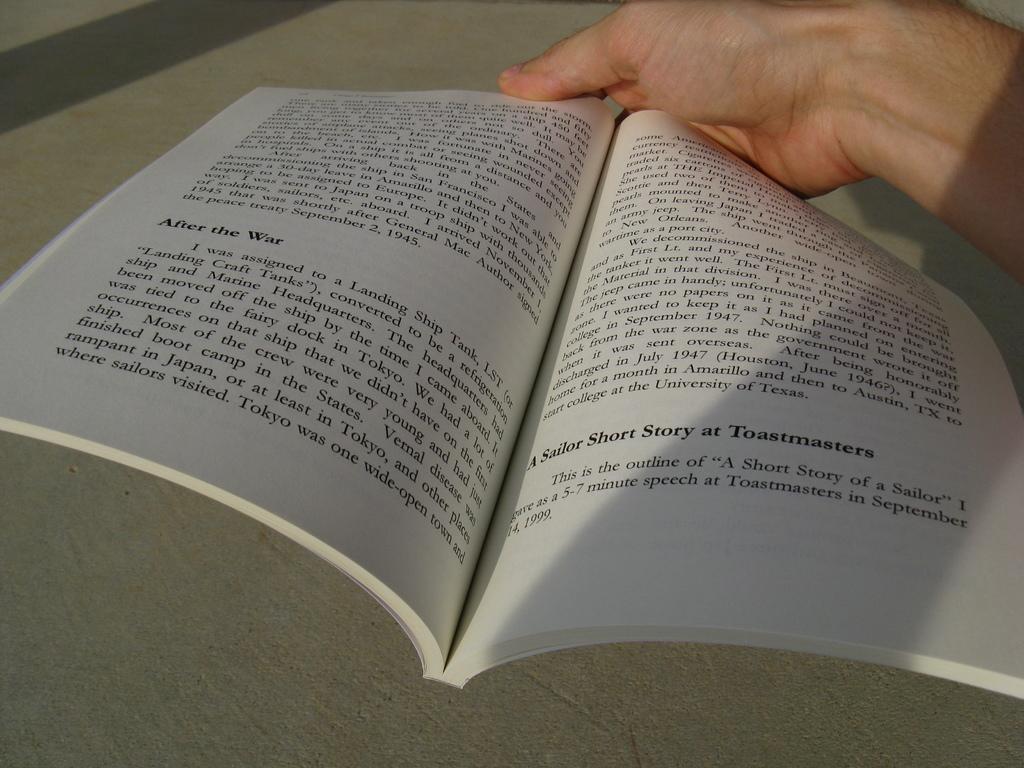What does the heading say in bold on the left page near the bottom?
Keep it short and to the point. After the war. 